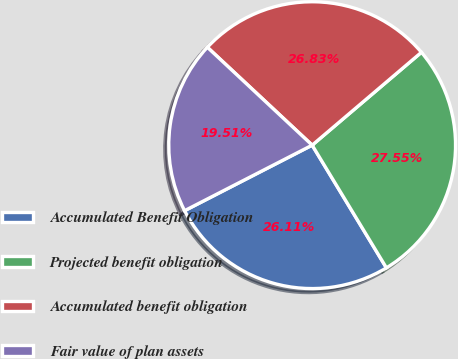Convert chart to OTSL. <chart><loc_0><loc_0><loc_500><loc_500><pie_chart><fcel>Accumulated Benefit Obligation<fcel>Projected benefit obligation<fcel>Accumulated benefit obligation<fcel>Fair value of plan assets<nl><fcel>26.11%<fcel>27.55%<fcel>26.83%<fcel>19.51%<nl></chart> 